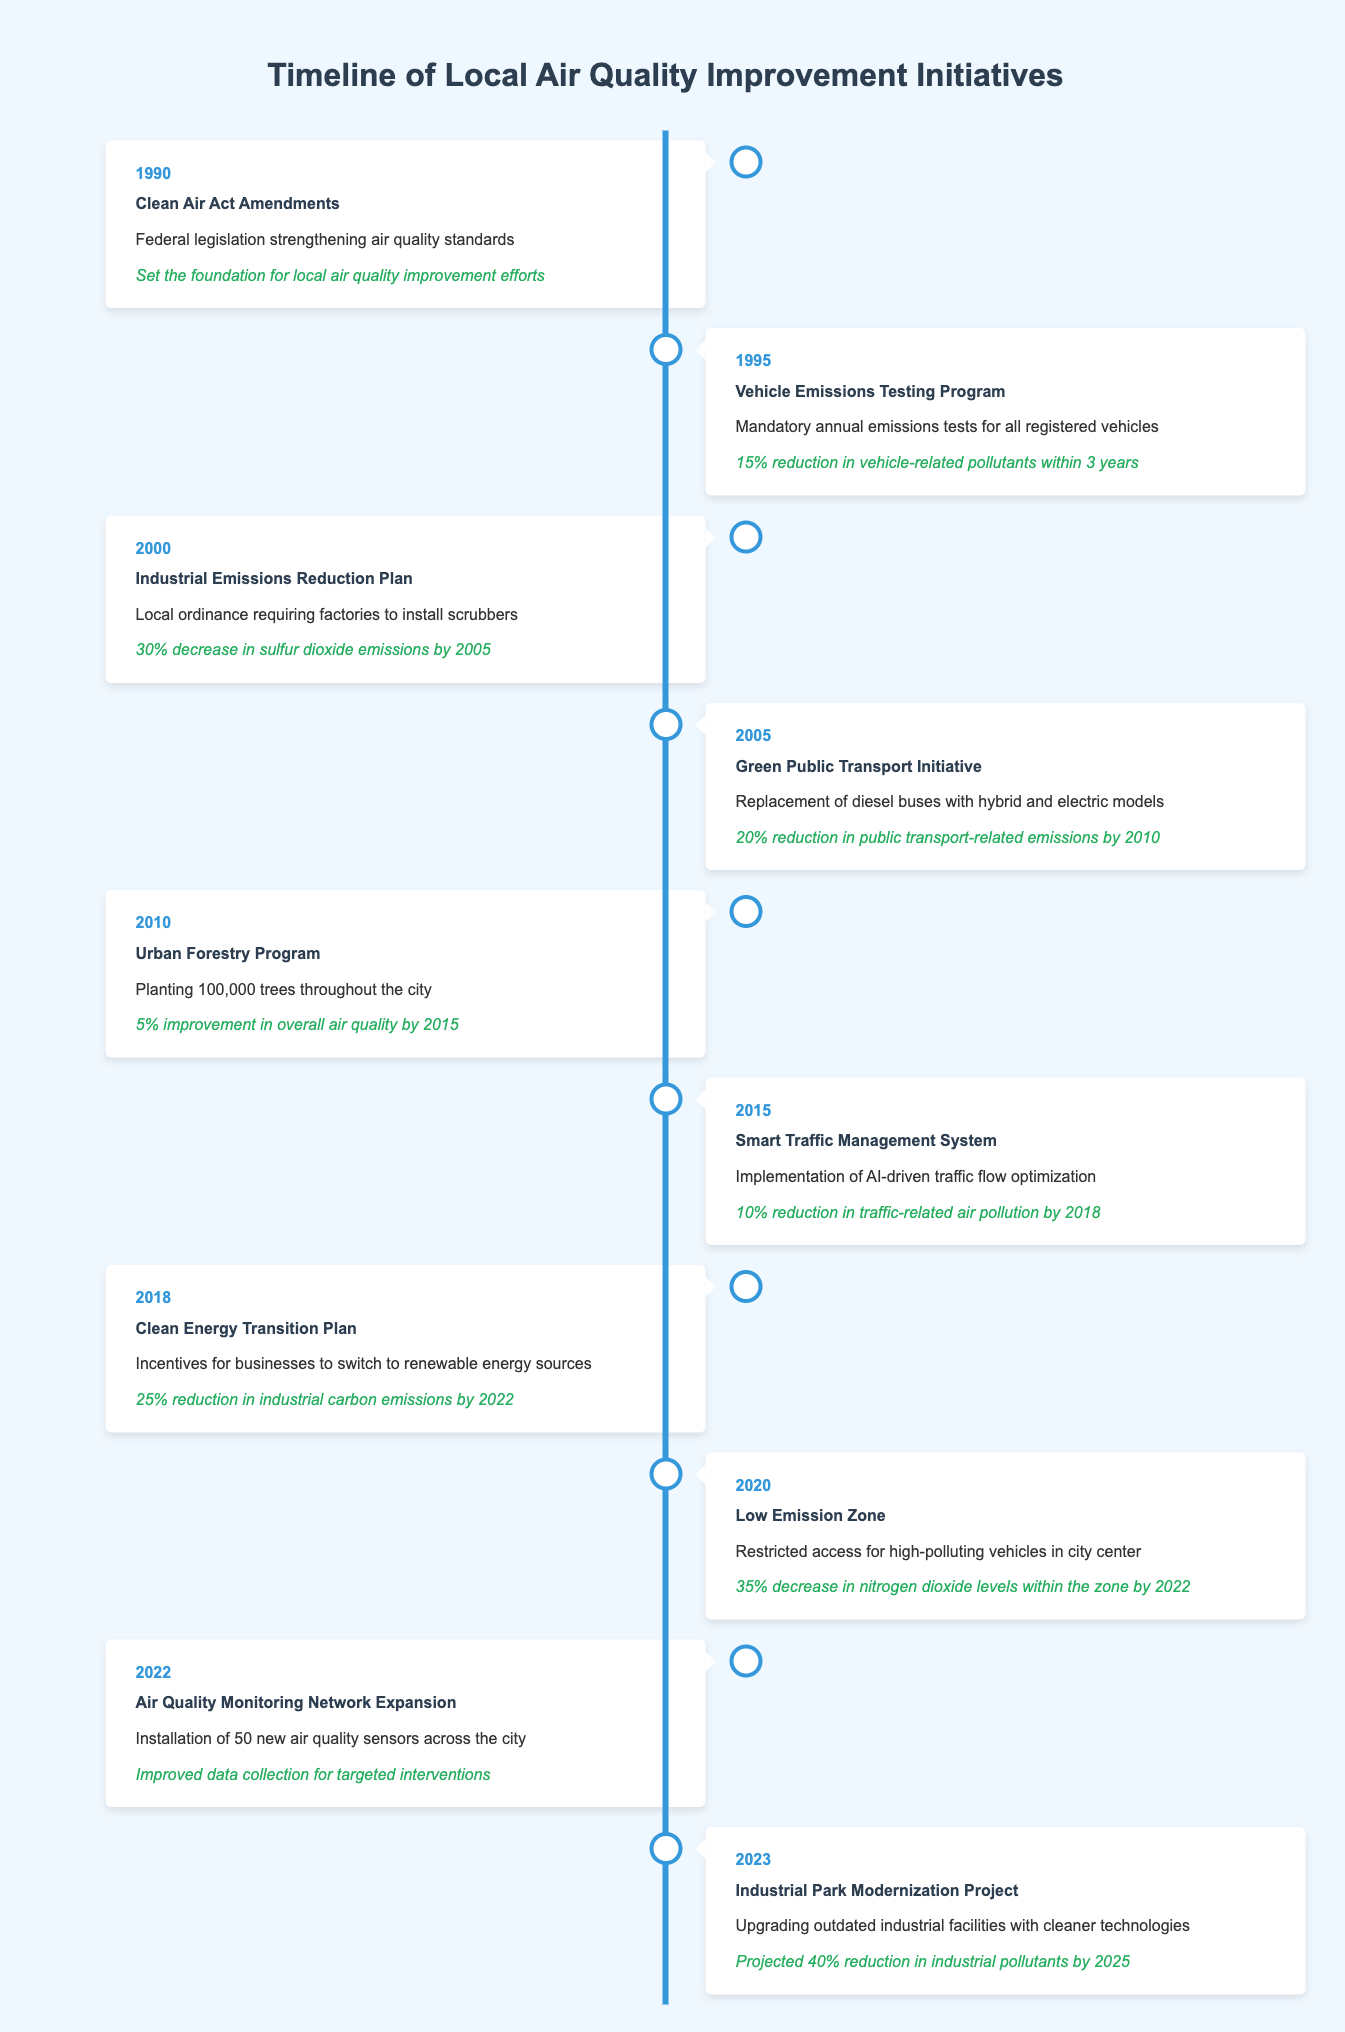What was the first air quality initiative mentioned in the timeline? The first initiative listed is the "Clean Air Act Amendments" in the year 1990. This is identified by looking at the first entry in the timeline table.
Answer: Clean Air Act Amendments How much reduction in vehicle-related pollutants was achieved by the Vehicle Emissions Testing Program? The "Vehicle Emissions Testing Program" implemented in 1995 achieved a 15% reduction in vehicle-related pollutants within 3 years. This is directly stated in its impact description.
Answer: 15% Which initiative had the highest percentage reduction in emissions? To determine this, we compare the impact percentages of each initiative. The "Low Emission Zone," initiated in 2020, reported a 35% decrease in nitrogen dioxide levels, which is the highest among the listed initiatives.
Answer: 35% Did the Urban Forestry Program contribute to improving air quality? Yes, the impact of the Urban Forestry Program, initiated in 2010, is a 5% improvement in overall air quality by 2015. This confirms that the initiative positively affected air quality.
Answer: Yes What is the projected reduction in industrial pollutants from the Industrial Park Modernization Project by 2025? The Industrial Park Modernization Project, initiated in 2023, has a projected 40% reduction in industrial pollutants by 2025. This information can be found in its impact description.
Answer: 40% What is the difference in percentage reduction between the Green Public Transport Initiative and the Smart Traffic Management System? The Green Public Transport Initiative had a 20% reduction in public transport-related emissions, while the Smart Traffic Management System reported a 10% reduction. The difference is calculated as 20% - 10% = 10%.
Answer: 10% Was there a specific initiative aimed at reducing industrial carbon emissions? Yes, the "Clean Energy Transition Plan" initiated in 2018 aimed at reducing industrial carbon emissions, achieving a 25% reduction by 2022 as mentioned in its impact statement.
Answer: Yes How many initiatives aimed to track or improve monitoring of air quality? Two initiatives specifically address monitoring: the "Air Quality Monitoring Network Expansion" in 2022 and the "Clean Air Act Amendments" in 1990, as it set the foundation for future monitoring efforts.
Answer: 2 Which initiative focused specifically on vehicle emissions and in what year was it implemented? The initiative that focused specifically on vehicle emissions is the "Vehicle Emissions Testing Program," which was implemented in 1995. This information is directly stated in its entry.
Answer: Vehicle Emissions Testing Program, 1995 